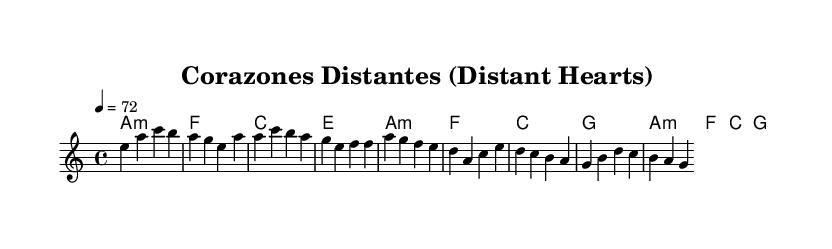What is the key signature of this music? The key signature is a minor, indicated by an 'a' at the beginning of the score, meaning that it includes the notes A, B, C, D, E, F, and G, with the following flats: A and C.
Answer: A minor What is the time signature of this piece? The time signature is 4/4, shown at the beginning of the score, indicating that there are four beats in each measure and the quarter note receives one beat.
Answer: 4/4 What is the tempo marking for this piece? The tempo marking is 72 beats per minute, indicated by the '4 = 72' following the tempo indication in the score, specifying the speed at which the piece should be played.
Answer: 72 How many measures are in the chorus section? The chorus consists of two measures, identifiable by the structure of the provided melody and harmonies, which outline the first part of the chorus with no additional lines in between.
Answer: 2 What type of chords are primarily used in the harmonies? The chords used in the harmonies are primarily minor and major chords, which can be deduced from the chord symbols, specifically identifying 'a1:m' as a minor chord and 'f', 'c', 'g' as major chords.
Answer: Minor and major What theme is represented in the title of this piece? The title "Corazones Distantes" translates to "Distant Hearts," which reflects the theme of exploring long-distance relationships, and is articulated through the lyrics and melody structure which evoke feelings of longing.
Answer: Long-distance relationships What role does the melody play in conveying emotion? The melody typically serves to express the emotional content of the lyrics, using specific note sequences and rhythms to evoke feelings of yearning, which is essential in Latin pop ballads that often deal with love and separation.
Answer: Express emotional content 